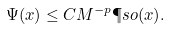<formula> <loc_0><loc_0><loc_500><loc_500>\Psi ( x ) \leq C M ^ { - p } \P s o ( x ) .</formula> 